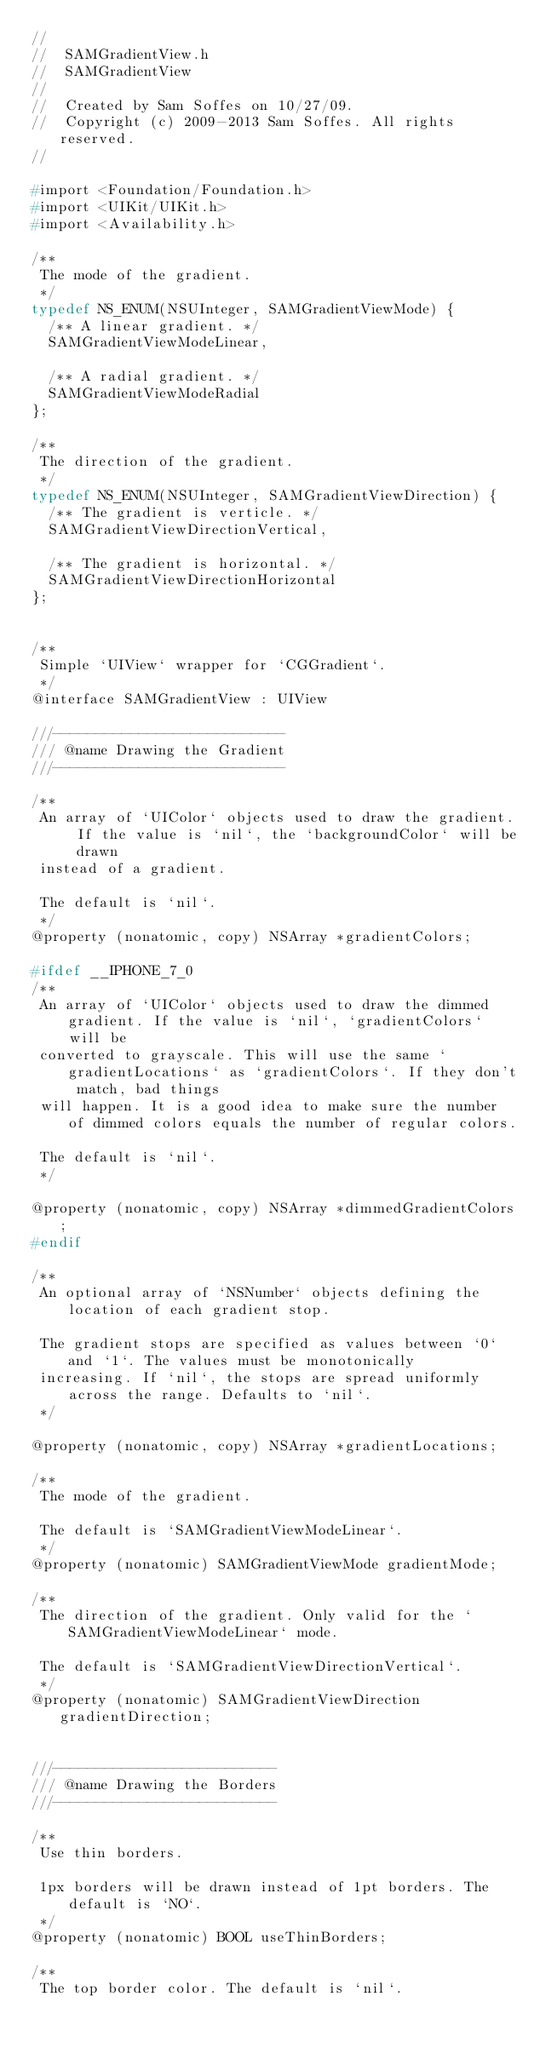<code> <loc_0><loc_0><loc_500><loc_500><_C_>//
//  SAMGradientView.h
//  SAMGradientView
//
//  Created by Sam Soffes on 10/27/09.
//  Copyright (c) 2009-2013 Sam Soffes. All rights reserved.
//

#import <Foundation/Foundation.h>
#import <UIKit/UIKit.h>
#import <Availability.h>

/**
 The mode of the gradient.
 */
typedef NS_ENUM(NSUInteger, SAMGradientViewMode) {
	/** A linear gradient. */
	SAMGradientViewModeLinear,

	/** A radial gradient. */
	SAMGradientViewModeRadial
};

/**
 The direction of the gradient.
 */
typedef NS_ENUM(NSUInteger, SAMGradientViewDirection) {
	/** The gradient is verticle. */
	SAMGradientViewDirectionVertical,

	/** The gradient is horizontal. */
	SAMGradientViewDirectionHorizontal
};


/**
 Simple `UIView` wrapper for `CGGradient`.
 */
@interface SAMGradientView : UIView

///---------------------------
/// @name Drawing the Gradient
///---------------------------

/**
 An array of `UIColor` objects used to draw the gradient. If the value is `nil`, the `backgroundColor` will be drawn
 instead of a gradient.

 The default is `nil`.
 */
@property (nonatomic, copy) NSArray *gradientColors;

#ifdef __IPHONE_7_0
/**
 An array of `UIColor` objects used to draw the dimmed gradient. If the value is `nil`, `gradientColors` will be
 converted to grayscale. This will use the same `gradientLocations` as `gradientColors`. If they don't match, bad things
 will happen. It is a good idea to make sure the number of dimmed colors equals the number of regular colors.
 
 The default is `nil`.
 */

@property (nonatomic, copy) NSArray *dimmedGradientColors;
#endif

/**
 An optional array of `NSNumber` objects defining the location of each gradient stop.

 The gradient stops are specified as values between `0` and `1`. The values must be monotonically
 increasing. If `nil`, the stops are spread uniformly across the range. Defaults to `nil`.
 */

@property (nonatomic, copy) NSArray *gradientLocations;

/**
 The mode of the gradient.

 The default is `SAMGradientViewModeLinear`.
 */
@property (nonatomic) SAMGradientViewMode gradientMode;

/**
 The direction of the gradient. Only valid for the `SAMGradientViewModeLinear` mode.

 The default is `SAMGradientViewDirectionVertical`.
 */
@property (nonatomic) SAMGradientViewDirection gradientDirection;


///--------------------------
/// @name Drawing the Borders
///--------------------------

/**
 Use thin borders.

 1px borders will be drawn instead of 1pt borders. The default is `NO`.
 */
@property (nonatomic) BOOL useThinBorders;

/**
 The top border color. The default is `nil`.
</code> 